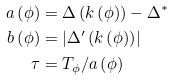Convert formula to latex. <formula><loc_0><loc_0><loc_500><loc_500>a \left ( \phi \right ) & = \Delta \left ( k \left ( \phi \right ) \right ) - \Delta ^ { \ast } \\ b \left ( \phi \right ) & = \left | \Delta ^ { \prime } \left ( k \left ( \phi \right ) \right ) \right | \\ \tau & = T _ { \phi } / a \left ( \phi \right )</formula> 